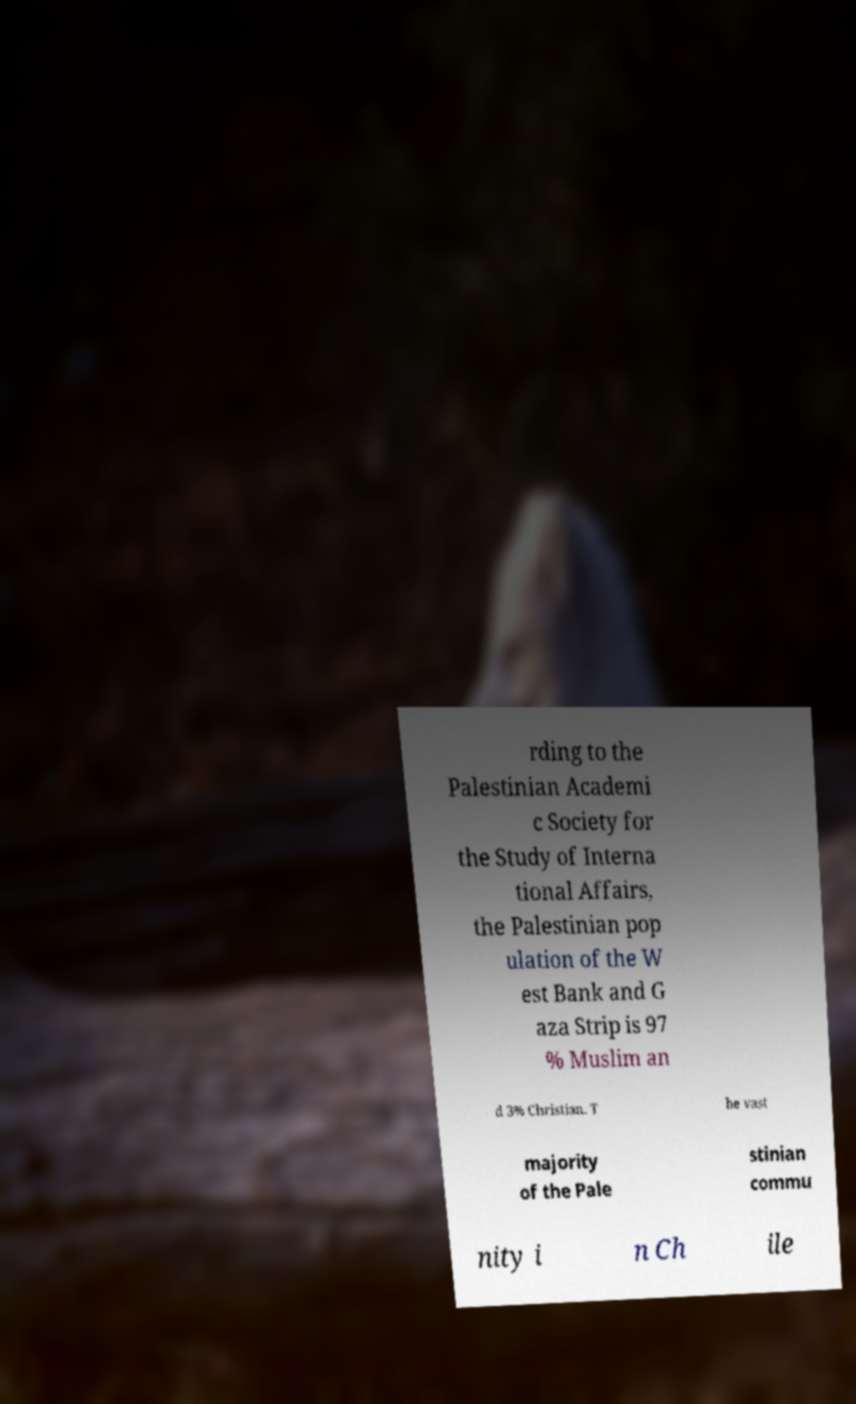There's text embedded in this image that I need extracted. Can you transcribe it verbatim? rding to the Palestinian Academi c Society for the Study of Interna tional Affairs, the Palestinian pop ulation of the W est Bank and G aza Strip is 97 % Muslim an d 3% Christian. T he vast majority of the Pale stinian commu nity i n Ch ile 